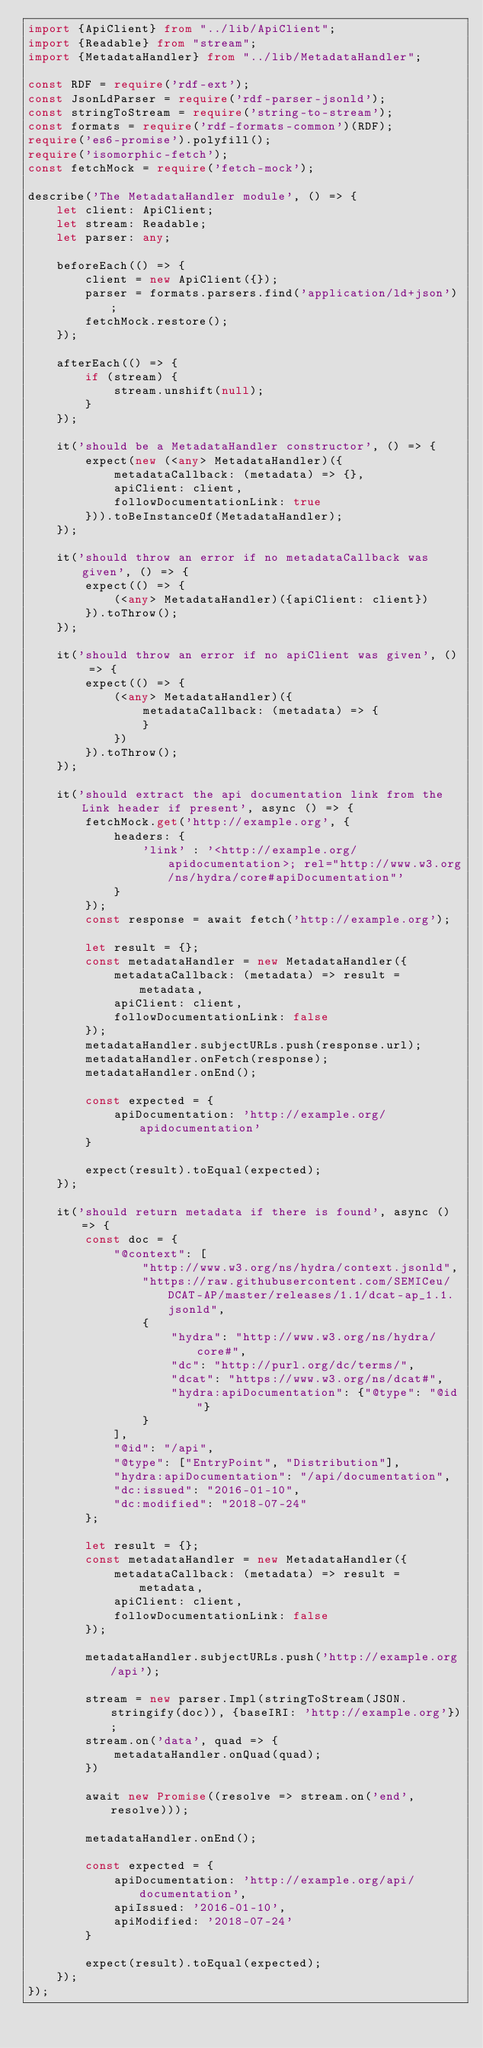Convert code to text. <code><loc_0><loc_0><loc_500><loc_500><_TypeScript_>import {ApiClient} from "../lib/ApiClient";
import {Readable} from "stream";
import {MetadataHandler} from "../lib/MetadataHandler";

const RDF = require('rdf-ext');
const JsonLdParser = require('rdf-parser-jsonld');
const stringToStream = require('string-to-stream');
const formats = require('rdf-formats-common')(RDF);
require('es6-promise').polyfill();
require('isomorphic-fetch');
const fetchMock = require('fetch-mock');

describe('The MetadataHandler module', () => {
    let client: ApiClient;
    let stream: Readable;
    let parser: any;

    beforeEach(() => {
        client = new ApiClient({});
        parser = formats.parsers.find('application/ld+json');
        fetchMock.restore();
    });

    afterEach(() => {
        if (stream) {
            stream.unshift(null);
        }
    });

    it('should be a MetadataHandler constructor', () => {
        expect(new (<any> MetadataHandler)({
            metadataCallback: (metadata) => {},
            apiClient: client,
            followDocumentationLink: true
        })).toBeInstanceOf(MetadataHandler);
    });

    it('should throw an error if no metadataCallback was given', () => {
        expect(() => {
            (<any> MetadataHandler)({apiClient: client})
        }).toThrow();
    });

    it('should throw an error if no apiClient was given', () => {
        expect(() => {
            (<any> MetadataHandler)({
                metadataCallback: (metadata) => {
                }
            })
        }).toThrow();
    });

    it('should extract the api documentation link from the Link header if present', async () => {
        fetchMock.get('http://example.org', {
            headers: {
                'link' : '<http://example.org/apidocumentation>; rel="http://www.w3.org/ns/hydra/core#apiDocumentation"'
            }
        });
        const response = await fetch('http://example.org');

        let result = {};
        const metadataHandler = new MetadataHandler({
            metadataCallback: (metadata) => result = metadata,
            apiClient: client,
            followDocumentationLink: false
        });
        metadataHandler.subjectURLs.push(response.url);
        metadataHandler.onFetch(response);
        metadataHandler.onEnd();

        const expected = {
            apiDocumentation: 'http://example.org/apidocumentation'
        }

        expect(result).toEqual(expected);
    });

    it('should return metadata if there is found', async () => {
        const doc = {
            "@context": [
                "http://www.w3.org/ns/hydra/context.jsonld",
                "https://raw.githubusercontent.com/SEMICeu/DCAT-AP/master/releases/1.1/dcat-ap_1.1.jsonld",
                {
                    "hydra": "http://www.w3.org/ns/hydra/core#",
                    "dc": "http://purl.org/dc/terms/",
                    "dcat": "https://www.w3.org/ns/dcat#",
                    "hydra:apiDocumentation": {"@type": "@id"}
                }
            ],
            "@id": "/api",
            "@type": ["EntryPoint", "Distribution"],
            "hydra:apiDocumentation": "/api/documentation",
            "dc:issued": "2016-01-10",
            "dc:modified": "2018-07-24"
        };

        let result = {};
        const metadataHandler = new MetadataHandler({
            metadataCallback: (metadata) => result = metadata,
            apiClient: client,
            followDocumentationLink: false
        });

        metadataHandler.subjectURLs.push('http://example.org/api');

        stream = new parser.Impl(stringToStream(JSON.stringify(doc)), {baseIRI: 'http://example.org'});
        stream.on('data', quad => {
            metadataHandler.onQuad(quad);
        })

        await new Promise((resolve => stream.on('end', resolve)));

        metadataHandler.onEnd();

        const expected = {
            apiDocumentation: 'http://example.org/api/documentation',
            apiIssued: '2016-01-10',
            apiModified: '2018-07-24'
        }

        expect(result).toEqual(expected);
    });
});
</code> 